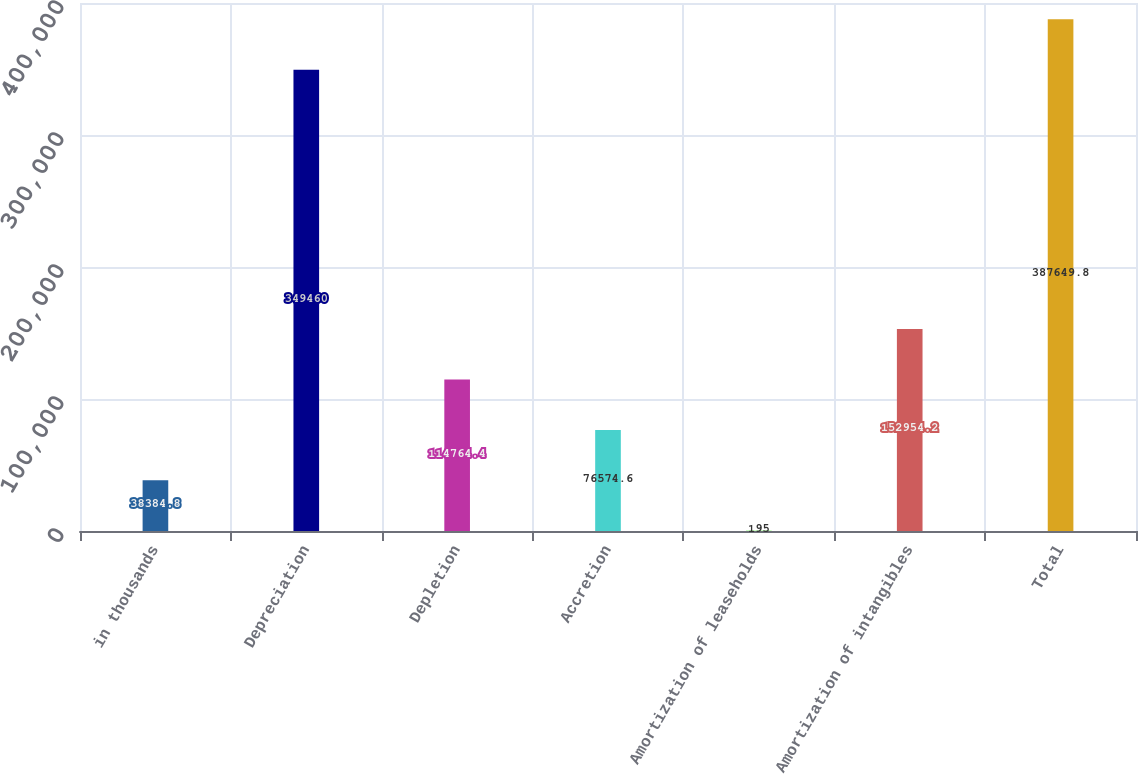Convert chart to OTSL. <chart><loc_0><loc_0><loc_500><loc_500><bar_chart><fcel>in thousands<fcel>Depreciation<fcel>Depletion<fcel>Accretion<fcel>Amortization of leaseholds<fcel>Amortization of intangibles<fcel>Total<nl><fcel>38384.8<fcel>349460<fcel>114764<fcel>76574.6<fcel>195<fcel>152954<fcel>387650<nl></chart> 